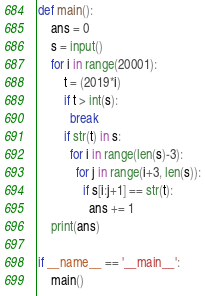<code> <loc_0><loc_0><loc_500><loc_500><_Python_>def main():
    ans = 0
    s = input()
    for i in range(20001):
        t = (2019*i)
        if t > int(s):
          break
        if str(t) in s:
          for i in range(len(s)-3):
            for j in range(i+3, len(s)):
              if s[i:j+1] == str(t):
                ans += 1
    print(ans)

if __name__ == '__main__':
    main()</code> 